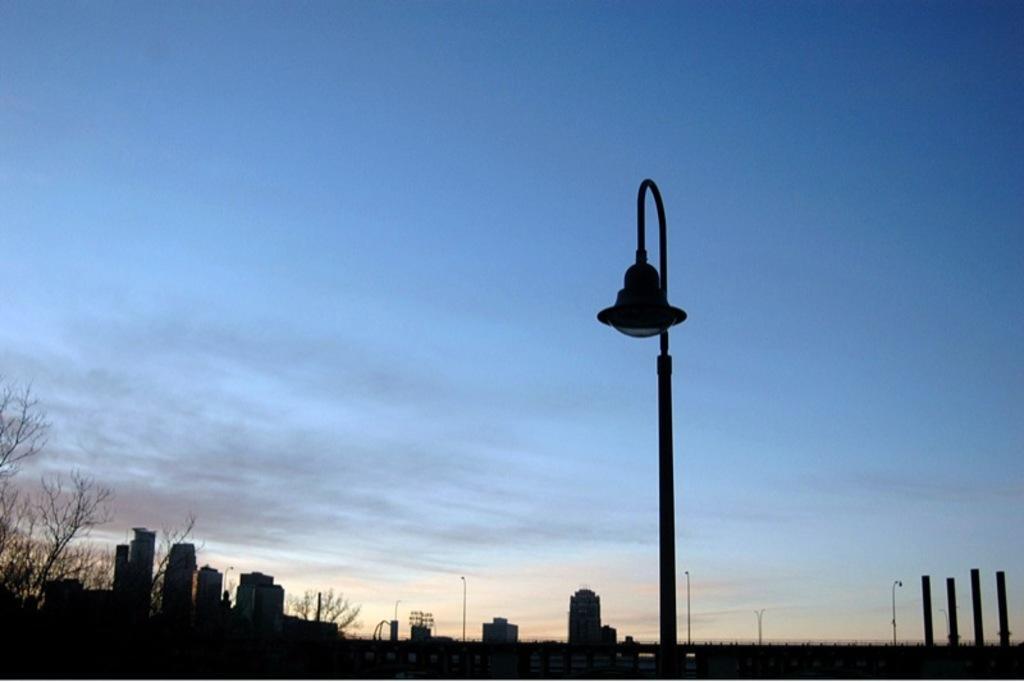Can you describe this image briefly? In this image, It looks like a light pole. I can see the buildings. On the left side of the image, these look like the trees. I think these are the poles. This is the sky. 